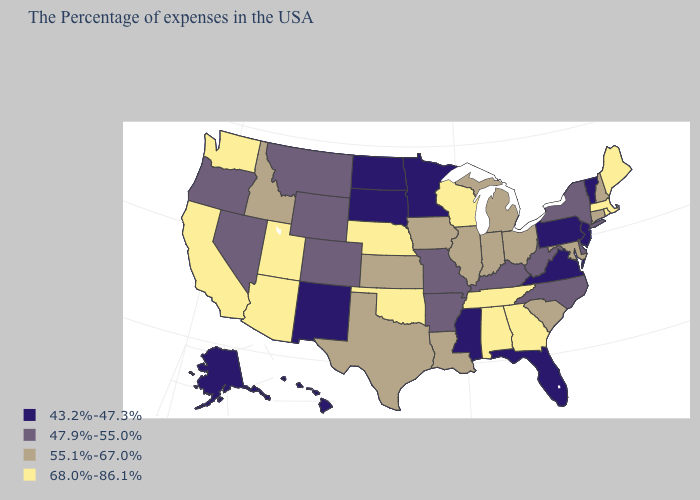Name the states that have a value in the range 43.2%-47.3%?
Write a very short answer. Vermont, New Jersey, Pennsylvania, Virginia, Florida, Mississippi, Minnesota, South Dakota, North Dakota, New Mexico, Alaska, Hawaii. Which states have the highest value in the USA?
Concise answer only. Maine, Massachusetts, Rhode Island, Georgia, Alabama, Tennessee, Wisconsin, Nebraska, Oklahoma, Utah, Arizona, California, Washington. What is the highest value in the West ?
Quick response, please. 68.0%-86.1%. What is the value of Kansas?
Quick response, please. 55.1%-67.0%. Is the legend a continuous bar?
Give a very brief answer. No. Name the states that have a value in the range 68.0%-86.1%?
Quick response, please. Maine, Massachusetts, Rhode Island, Georgia, Alabama, Tennessee, Wisconsin, Nebraska, Oklahoma, Utah, Arizona, California, Washington. Does Missouri have a higher value than Kentucky?
Write a very short answer. No. Which states have the lowest value in the USA?
Write a very short answer. Vermont, New Jersey, Pennsylvania, Virginia, Florida, Mississippi, Minnesota, South Dakota, North Dakota, New Mexico, Alaska, Hawaii. Which states have the lowest value in the South?
Short answer required. Virginia, Florida, Mississippi. Does Iowa have the lowest value in the USA?
Keep it brief. No. Name the states that have a value in the range 68.0%-86.1%?
Write a very short answer. Maine, Massachusetts, Rhode Island, Georgia, Alabama, Tennessee, Wisconsin, Nebraska, Oklahoma, Utah, Arizona, California, Washington. What is the value of California?
Quick response, please. 68.0%-86.1%. What is the value of Kentucky?
Quick response, please. 47.9%-55.0%. Does the first symbol in the legend represent the smallest category?
Write a very short answer. Yes. What is the value of Wyoming?
Keep it brief. 47.9%-55.0%. 